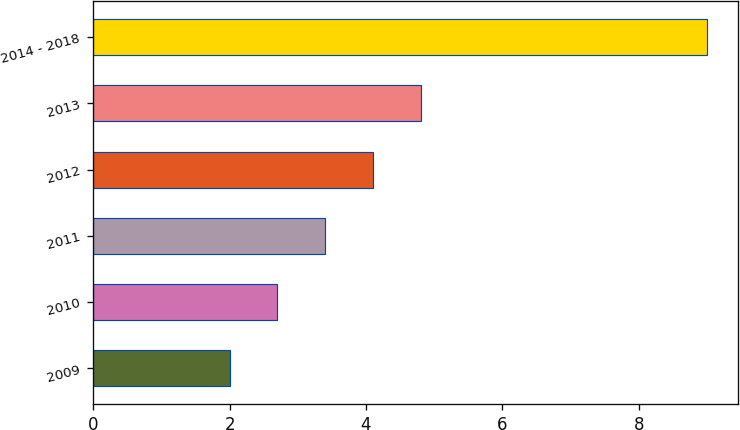Convert chart. <chart><loc_0><loc_0><loc_500><loc_500><bar_chart><fcel>2009<fcel>2010<fcel>2011<fcel>2012<fcel>2013<fcel>2014 - 2018<nl><fcel>2<fcel>2.7<fcel>3.4<fcel>4.1<fcel>4.8<fcel>9<nl></chart> 